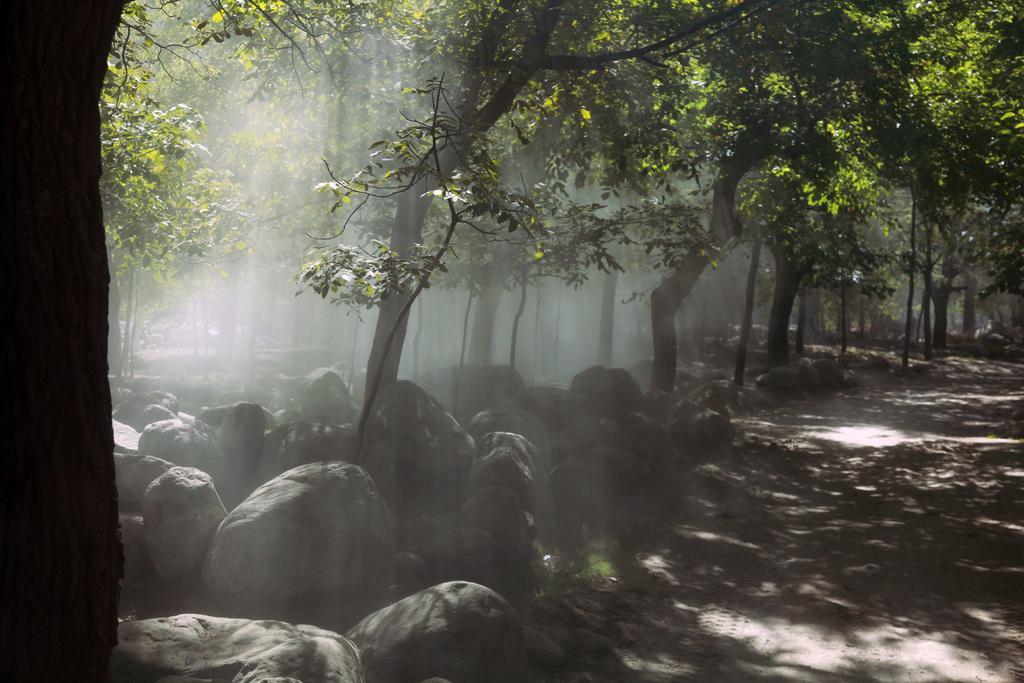Please provide a concise description of this image. In this picture there are rocks at the bottom side of the image and there are trees in the background area of the image. 